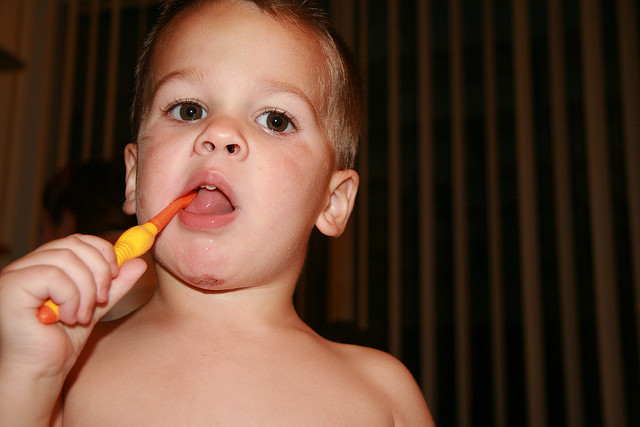<image>What fruit is the child holding? I don't know what the child is holding. It could be an apple, a carrot, an orange or a toothbrush, or there could be nothing. What fruit is the child holding? I don't know what fruit the child is holding. It can be seen as apple, carrot or orange. 